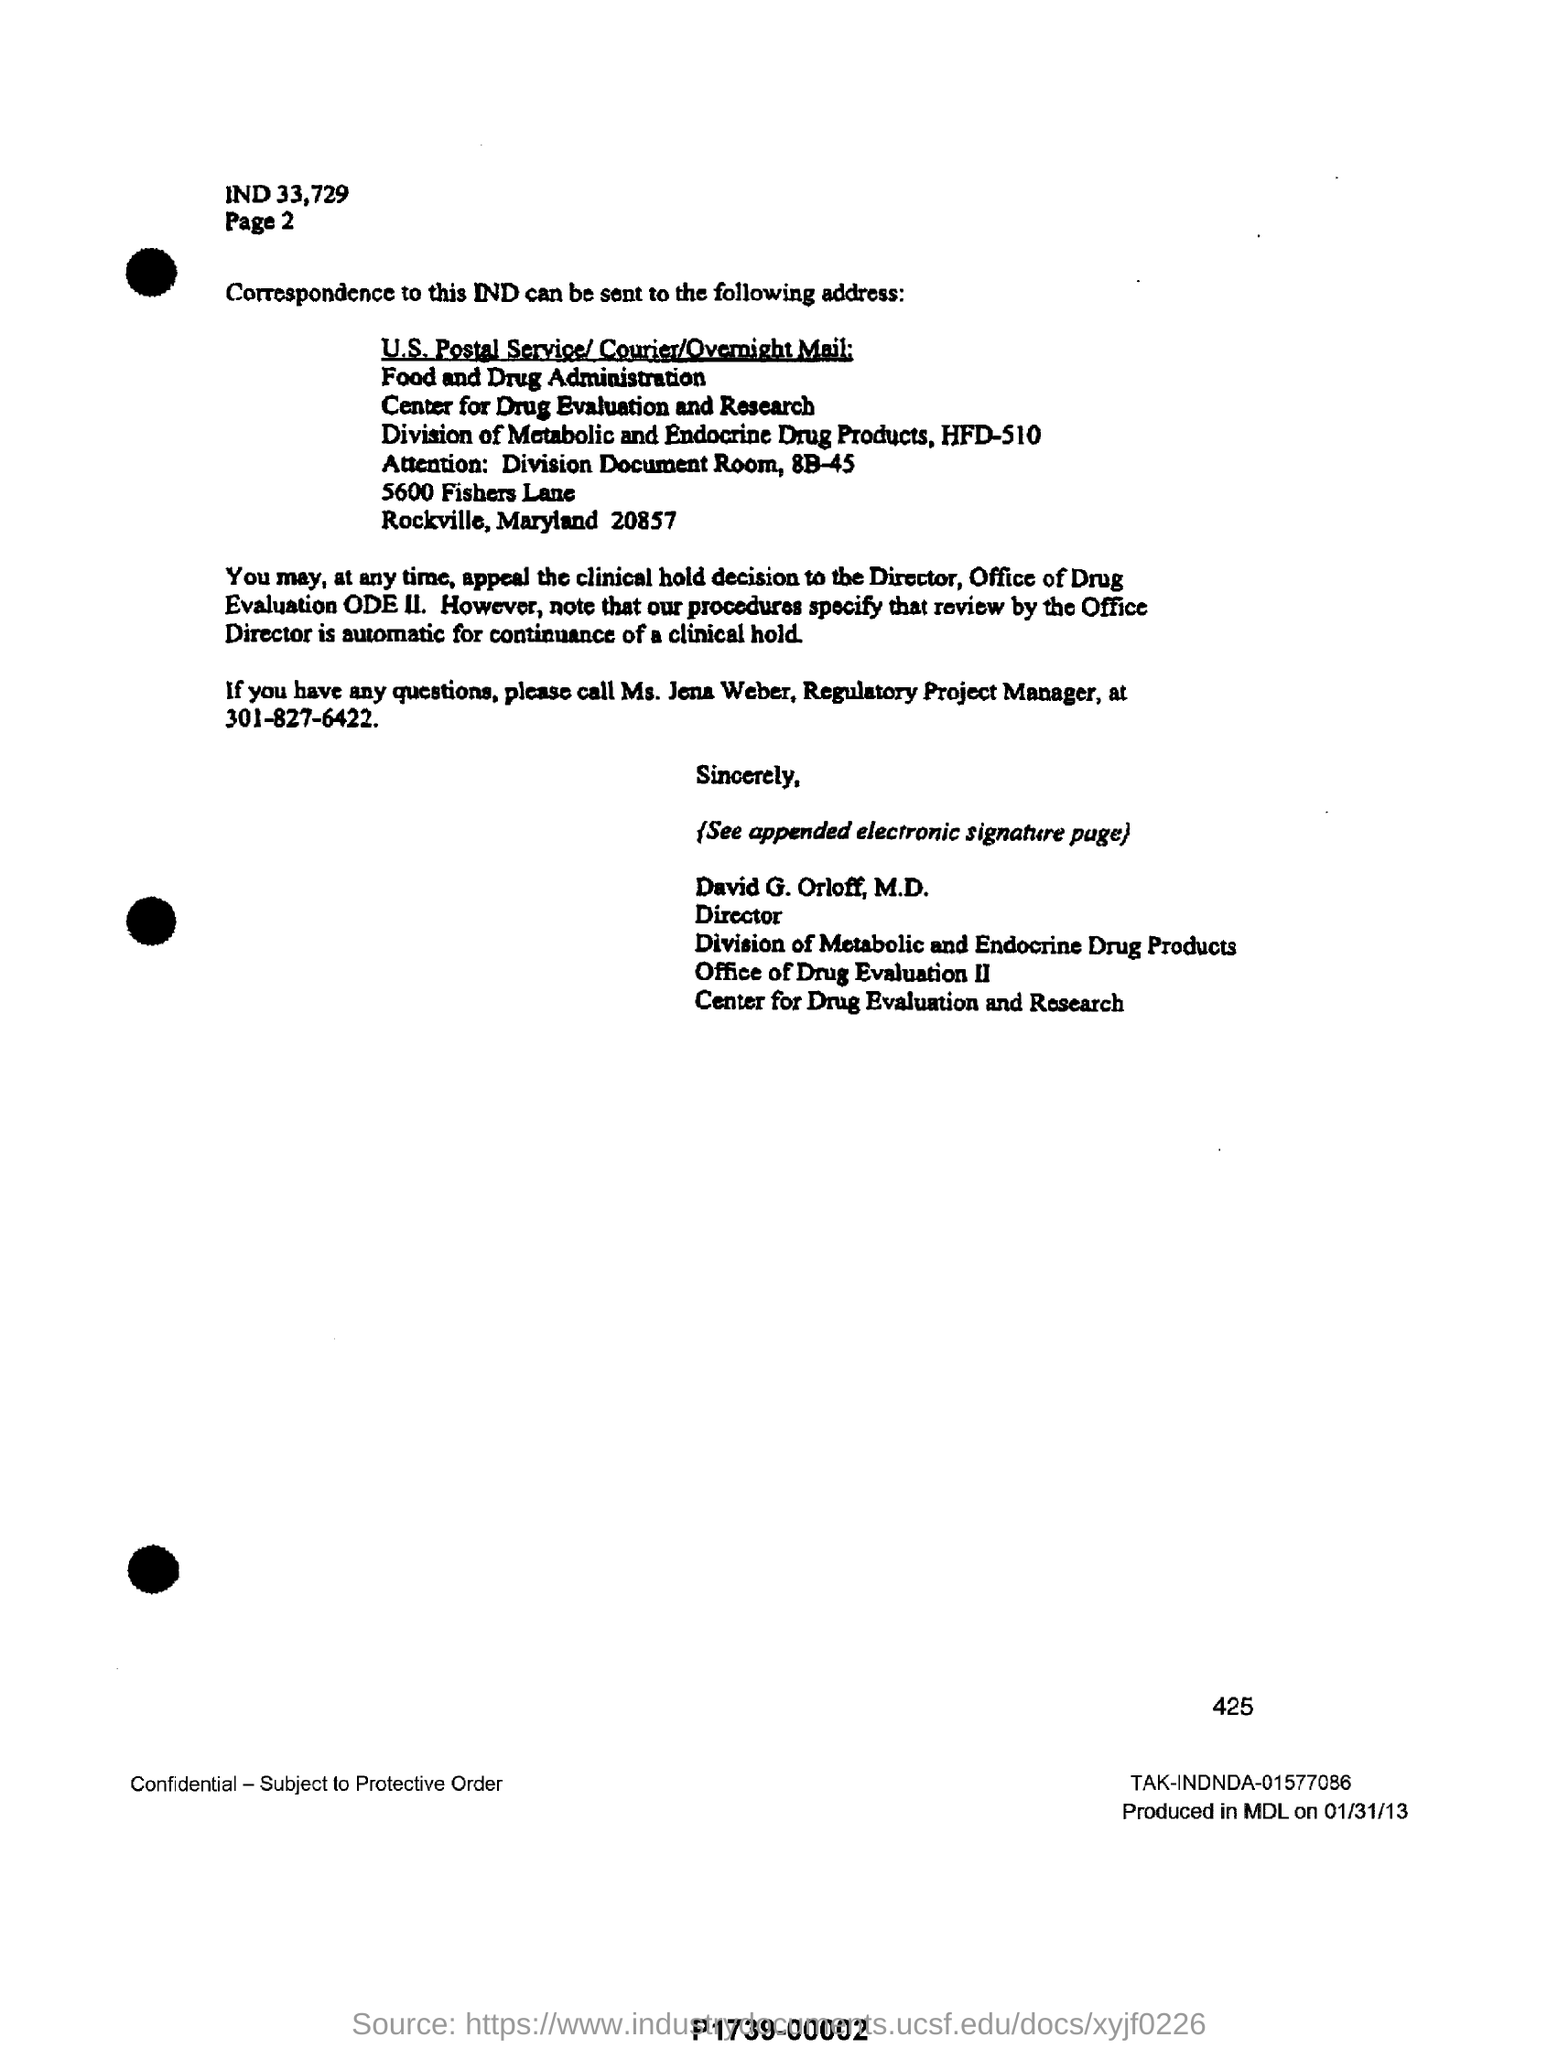What is the number written above TAK-INDNDA-01577086?
Give a very brief answer. 425. What is the contact number of Ms. Jena Weber, Regulatory Project Manager?
Ensure brevity in your answer.  301-827-6422. What is the full form of ODE?
Give a very brief answer. Office of Drug Evaluation. What is written above Page 2 on the top?
Keep it short and to the point. IND 33, 729. 